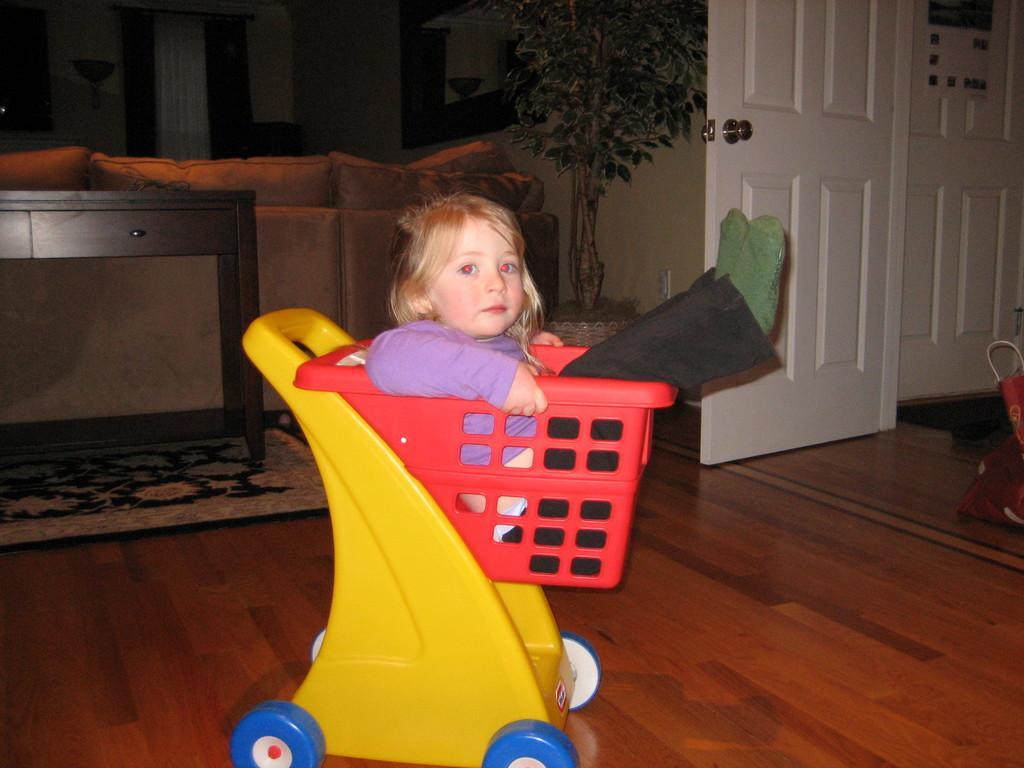Describe this image in one or two sentences. In this image there is a girl sitting in a toy basket and in back ground there is table , couch , pillow , plant , door, carpet. 